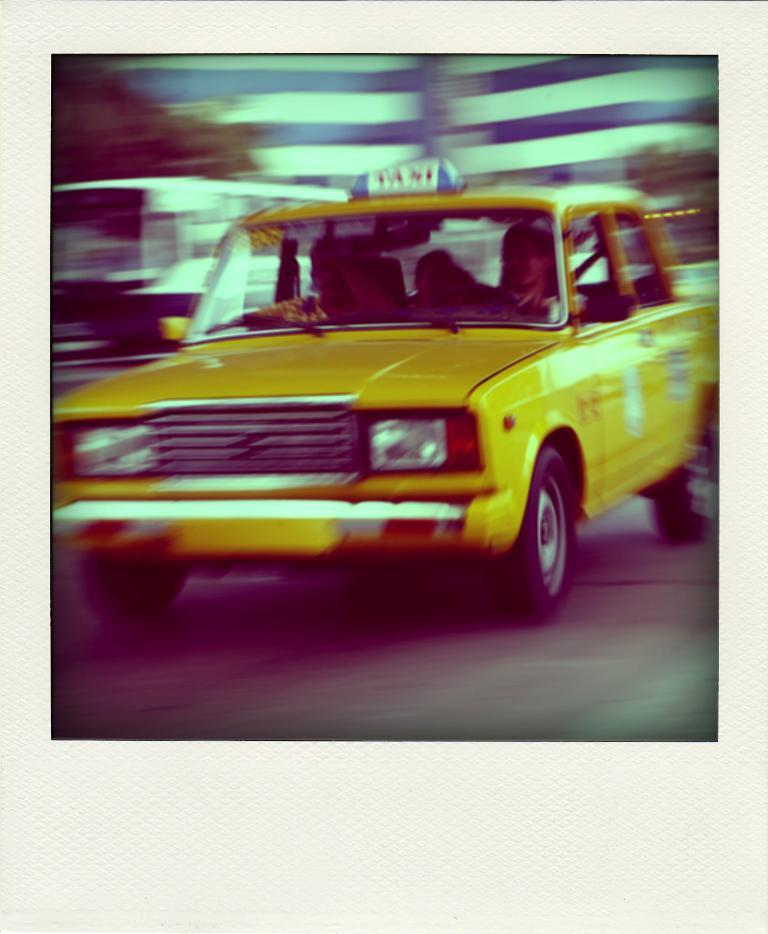<image>
Share a concise interpretation of the image provided. A yellow Taxi streaks down the road to pick up a passenger. 